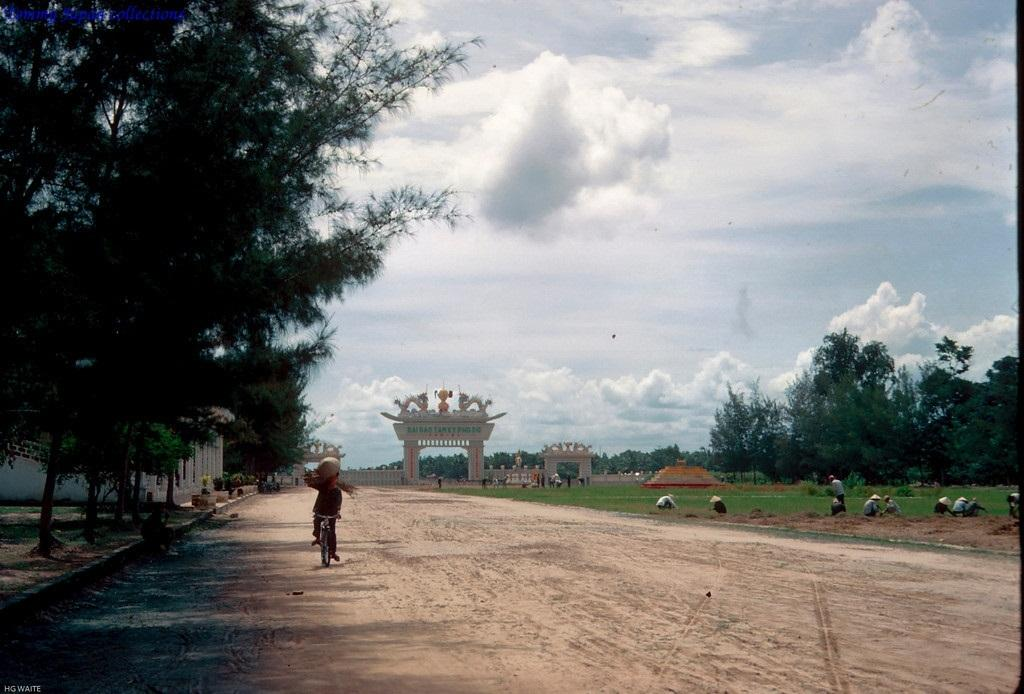What type of natural elements can be seen in the image? There are trees and clouds visible in the image. What part of the natural environment is visible in the image? The sky is visible in the image. What type of man-made structure is present in the image? There is a building in the image. Are there any living beings present in the image? Yes, there are people in the image. What type of brush is being used to paint the clouds in the image? There is no indication in the image that anyone is painting the clouds, and therefore no brush is present. 